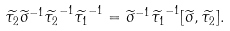Convert formula to latex. <formula><loc_0><loc_0><loc_500><loc_500>\widetilde { \tau _ { 2 } } { \widetilde { \sigma } } ^ { - 1 } { \widetilde { \tau _ { 2 } } } ^ { - 1 } { \widetilde { \tau _ { 1 } } } ^ { - 1 } = { \widetilde { \sigma } } ^ { - 1 } { \widetilde { \tau _ { 1 } } } ^ { - 1 } [ \widetilde { \sigma } , \widetilde { \tau _ { 2 } } ] .</formula> 